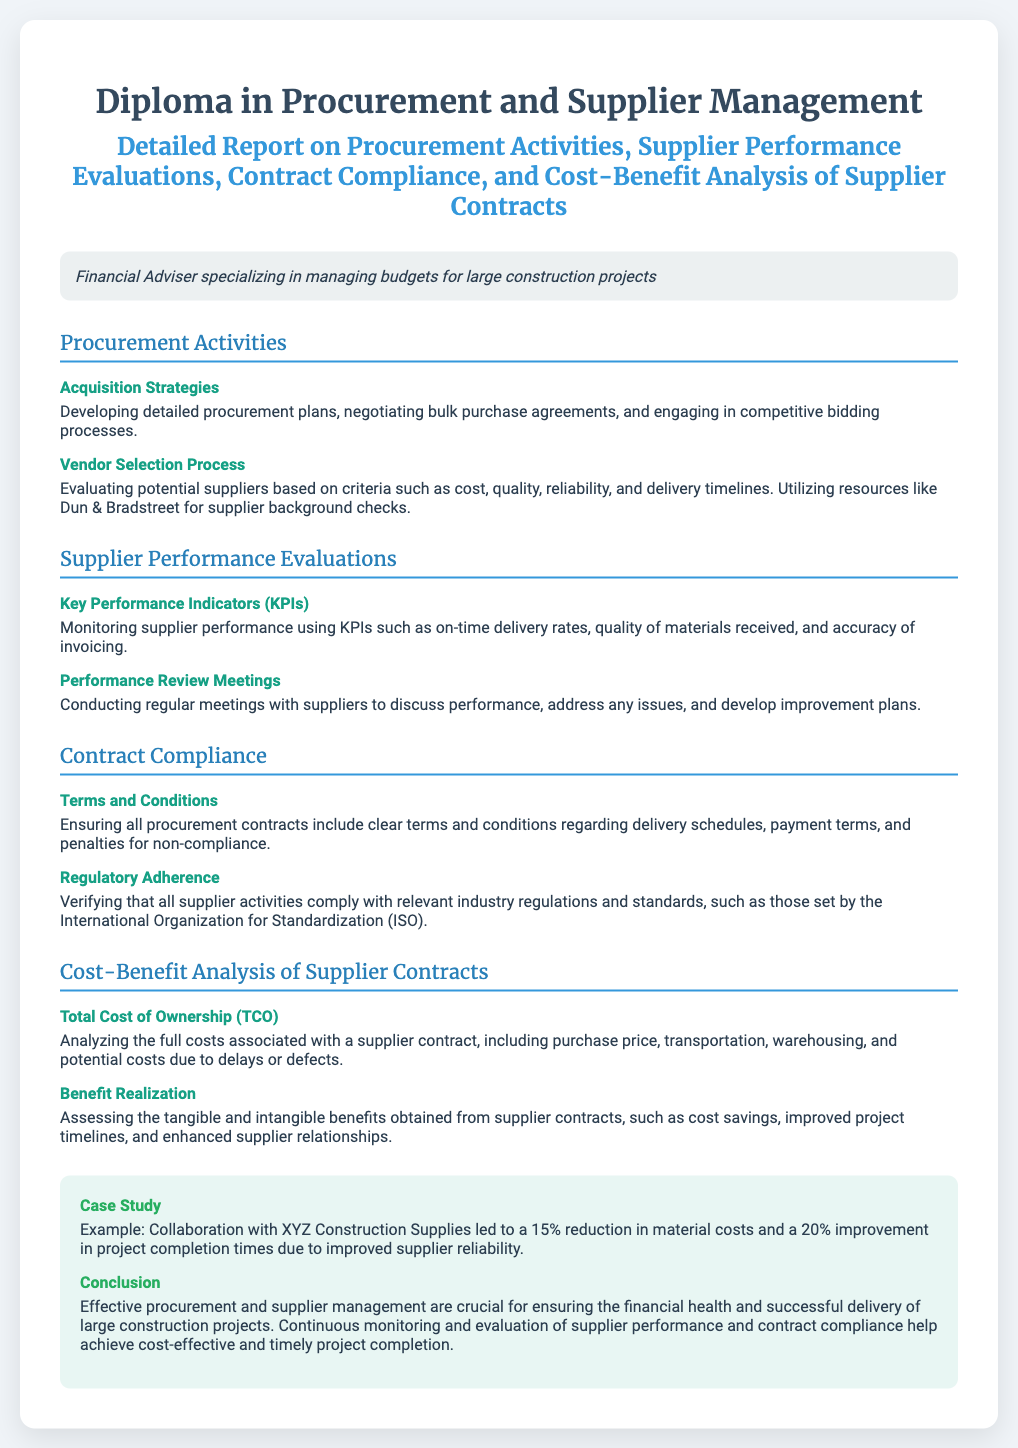What are the key procurement activities? The document outlines acquisition strategies and vendor selection processes as the key procurement activities.
Answer: Acquisition strategies, Vendor selection process What does KPI stand for in supplier performance evaluations? KPI is mentioned in the section about Supplier Performance Evaluations, referring to Key Performance Indicators.
Answer: Key Performance Indicators What is the total cost of ownership? The Total Cost of Ownership (TCO) refers to the full costs associated with a supplier contract including various factors.
Answer: Total Cost of Ownership Which regulatory organization is mentioned in the document? The document refers to the International Organization for Standardization (ISO) regarding regulatory adherence.
Answer: International Organization for Standardization (ISO) How much reduction in material costs was achieved with XYZ Construction Supplies? The case study states that collaboration led to a reduction of 15% in material costs.
Answer: 15% What meeting type is used for supplier performance discussions? The document lists Performance Review Meetings as the format for discussing supplier performance.
Answer: Performance Review Meetings What is one of the benefits assessed from supplier contracts? Benefit realization includes assessing cost savings as one of the benefits obtained from supplier contracts.
Answer: Cost savings What is the overall conclusion about procurement and supplier management? The document concludes that effective procurement and supplier management are crucial for financial health and project delivery.
Answer: Crucial for financial health and successful delivery What are the criteria for evaluating potential suppliers? Potential suppliers are evaluated based on criteria such as cost, quality, reliability, and delivery timelines.
Answer: Cost, quality, reliability, delivery timelines 